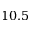<formula> <loc_0><loc_0><loc_500><loc_500>1 0 . 5</formula> 